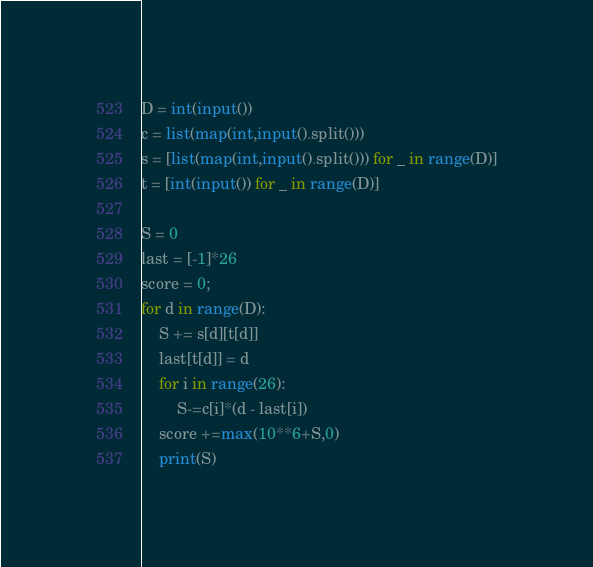Convert code to text. <code><loc_0><loc_0><loc_500><loc_500><_Python_>D = int(input())
c = list(map(int,input().split()))
s = [list(map(int,input().split())) for _ in range(D)]
t = [int(input()) for _ in range(D)]

S = 0
last = [-1]*26
score = 0;
for d in range(D):
    S += s[d][t[d]]
    last[t[d]] = d
    for i in range(26):
        S-=c[i]*(d - last[i])
    score +=max(10**6+S,0)
    print(S)
</code> 